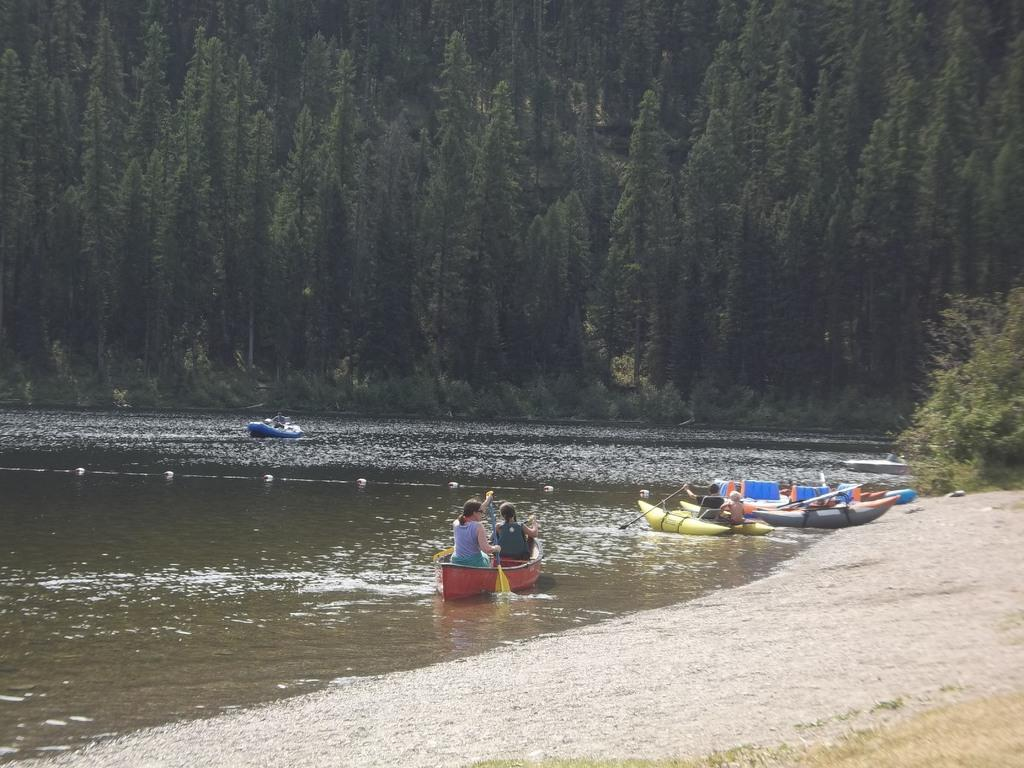What is the main feature in the foreground of the image? There is a river in the foreground of the image. What is on the river? There are boats on the river. What can be seen in the right bottom corner of the image? There is ground visible in the right bottom corner of the image, and there are trees near the ground. What is visible in the background of the image? There are trees in the background of the image. How many records can be seen on the ground near the hole in the image? There are no records or holes present in the image; it features a river, boats, and trees. 